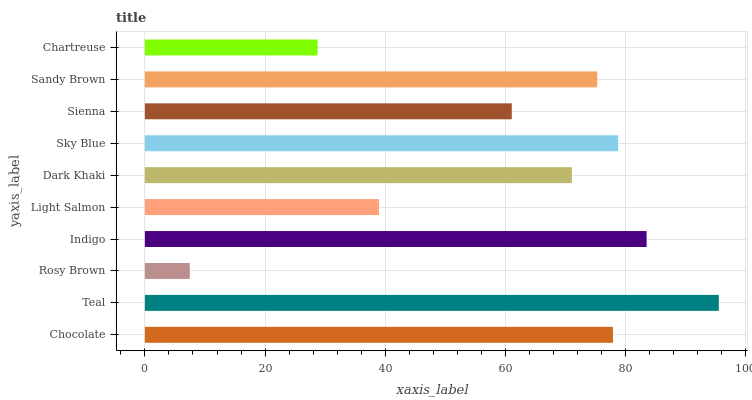Is Rosy Brown the minimum?
Answer yes or no. Yes. Is Teal the maximum?
Answer yes or no. Yes. Is Teal the minimum?
Answer yes or no. No. Is Rosy Brown the maximum?
Answer yes or no. No. Is Teal greater than Rosy Brown?
Answer yes or no. Yes. Is Rosy Brown less than Teal?
Answer yes or no. Yes. Is Rosy Brown greater than Teal?
Answer yes or no. No. Is Teal less than Rosy Brown?
Answer yes or no. No. Is Sandy Brown the high median?
Answer yes or no. Yes. Is Dark Khaki the low median?
Answer yes or no. Yes. Is Teal the high median?
Answer yes or no. No. Is Teal the low median?
Answer yes or no. No. 